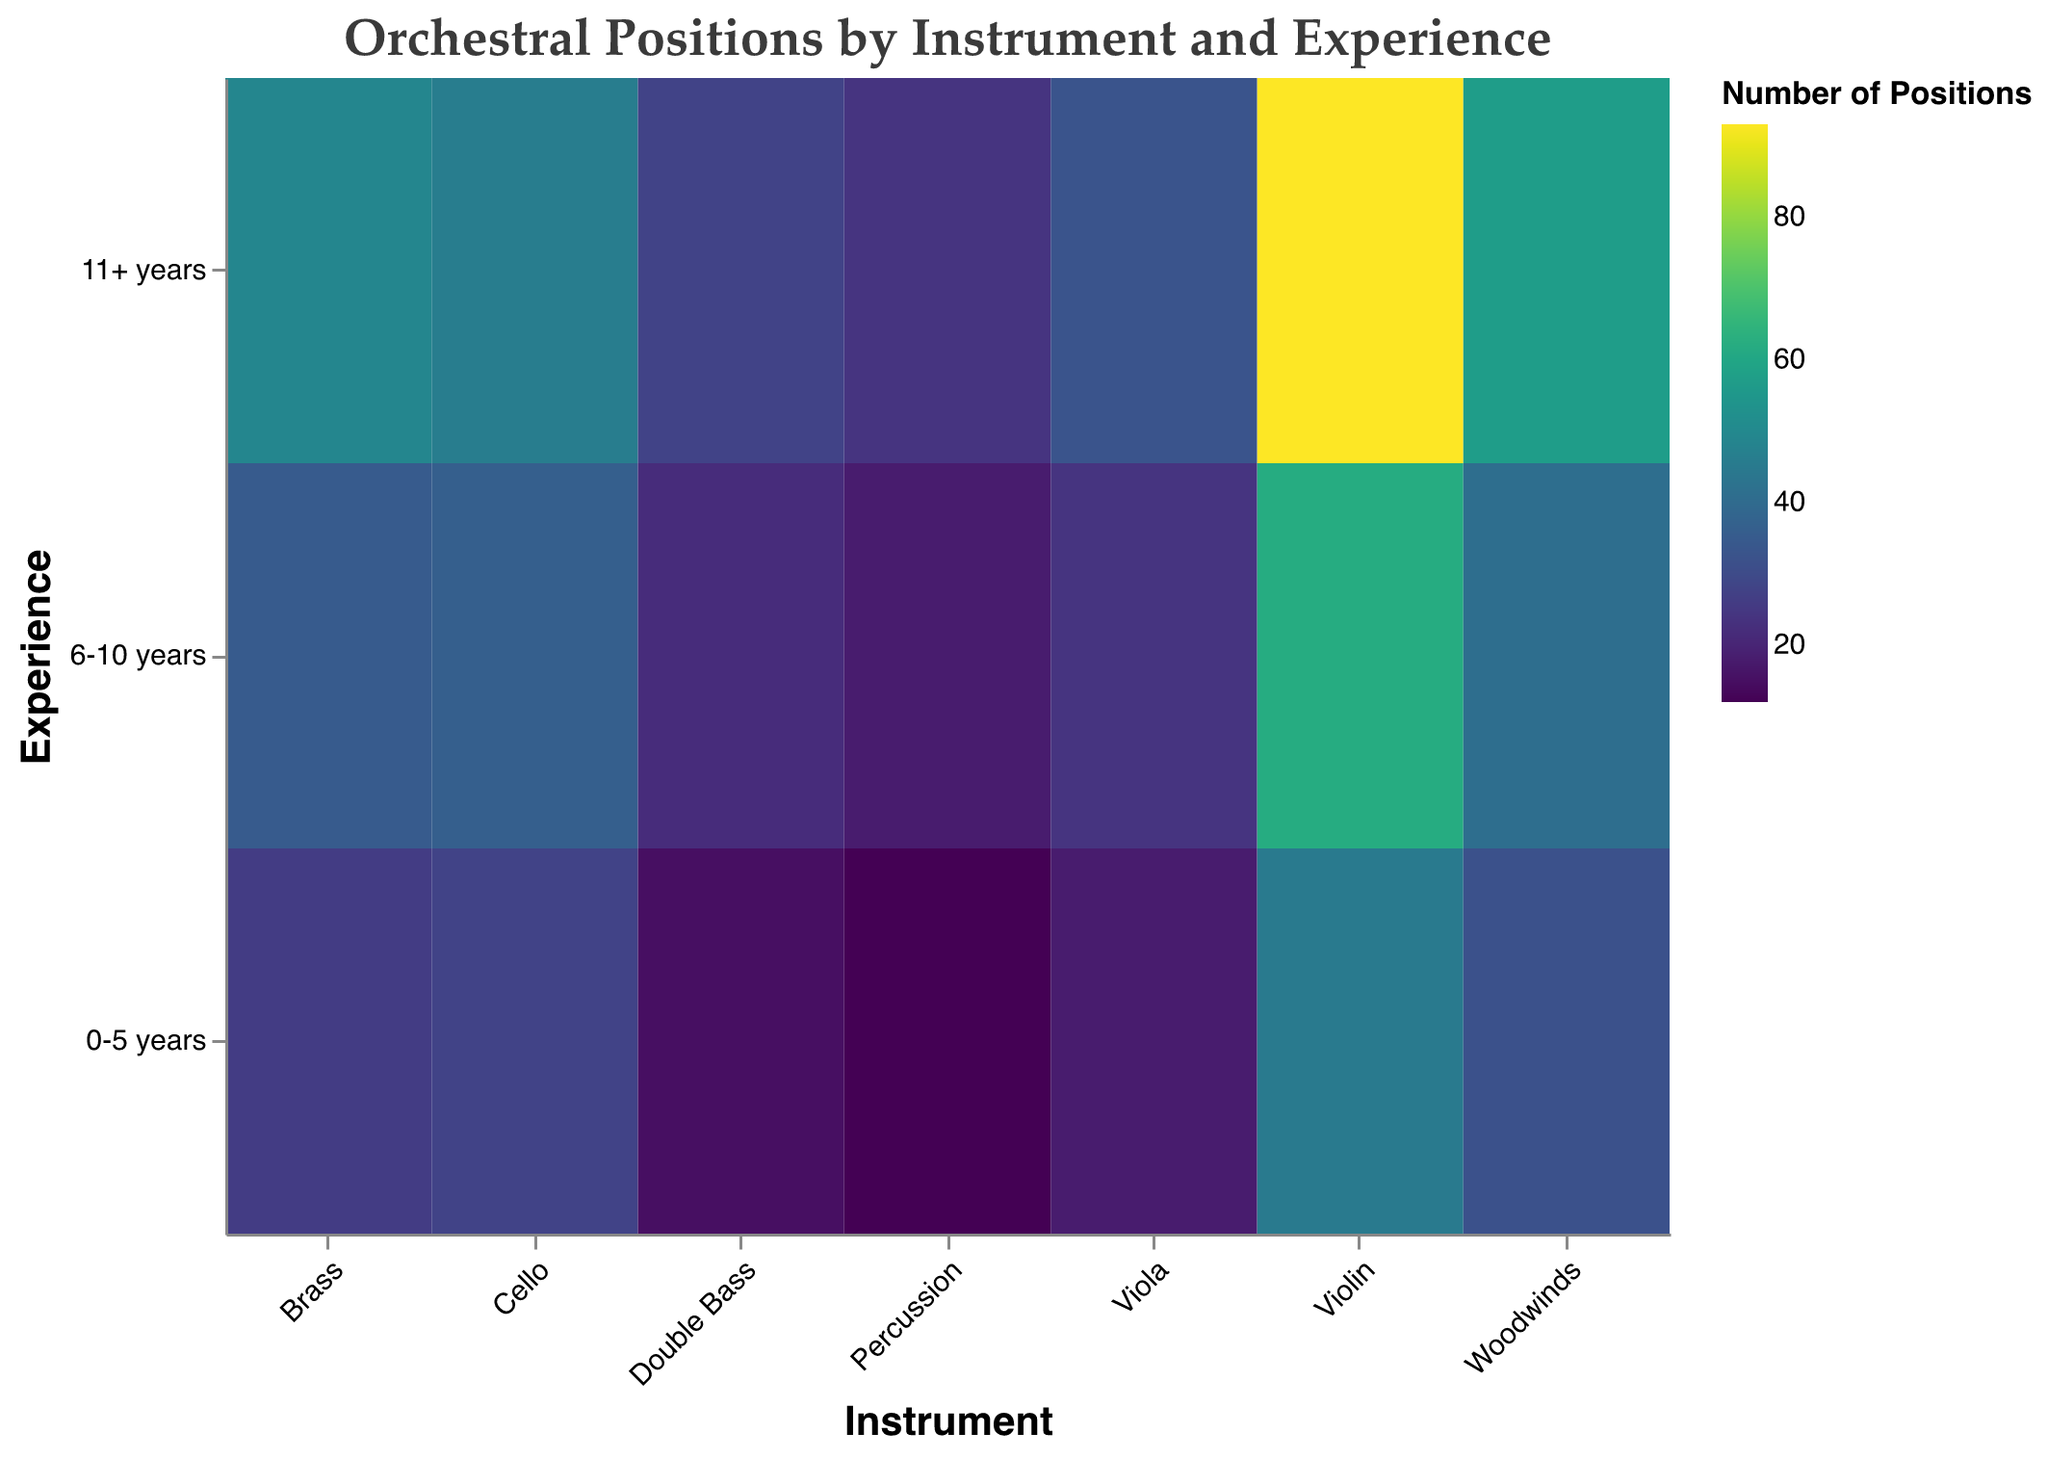How many violinists have 11+ years of experience? The number of positions for violinists with over 11 years of experience is labeled as 93 in the plot.
Answer: 93 Which instrument category has the least number of positions for those with 0-5 years of experience? By looking at the "0-5 years" experience level across all instruments, Percussion has the least number with 12.
Answer: Percussion Compare the number of positions for violas with 6-10 years of experience to cellos with the same experience level. Which is higher? The plot indicates that violas with 6-10 years of experience have 24 positions, while cellos have 36. 36 is higher than 24.
Answer: Cellos What is the total number of positions available for double bass players across all experience levels? Sum the counts for "0-5 years" (15), "6-10 years" (22), and "11+ years" (28) for the double bass category: 15 + 22 + 28 = 65.
Answer: 65 Identify which group has the maximum number of positions in the entire plot. The plot shows that violinists with 11+ years experience have the highest count with 93 positions.
Answer: Violin, 11+ years How does the number of woodwinds positions with 0-5 years of experience compare to the number of brass positions with the same experience level? The woodwinds have 32 positions, and the brass have 26. Since 32 > 26, woodwinds have more.
Answer: Woodwinds Calculate the average number of positions for cellos in each experience category. Sum the counts for cellos (28 + 36 + 46), which equals 110, then divide by the 3 experience levels (110 / 3 ≈ 36.67).
Answer: 36.67 Which instrument has the fewest combined positions for 6-10 years and 11+ years of experience? Add the "6-10 years" and "11+ years" counts for each instrument and find the minimum. Percussion: 18 + 24 = 42 is the lowest.
Answer: Percussion Compare the total positions of string instruments (violin, viola, cello, double bass) to non-string instruments (woodwinds, brass, percussion). Which category has more positions? Sum the individual counts for string instruments (Violin: 200, Viola: 75, Cello: 110, Double Bass: 65) to get 450. Sum the counts for non-string instruments (Woodwinds: 130, Brass: 110, Percussion: 54) to get 294. 450 is greater than 294.
Answer: String instruments What is the total number of positions available for instruments with 6-10 years of experience? Add the counts across all instruments for the "6-10 years" category: (62 + 24 + 36 + 22 + 41 + 35 + 18) = 238.
Answer: 238 